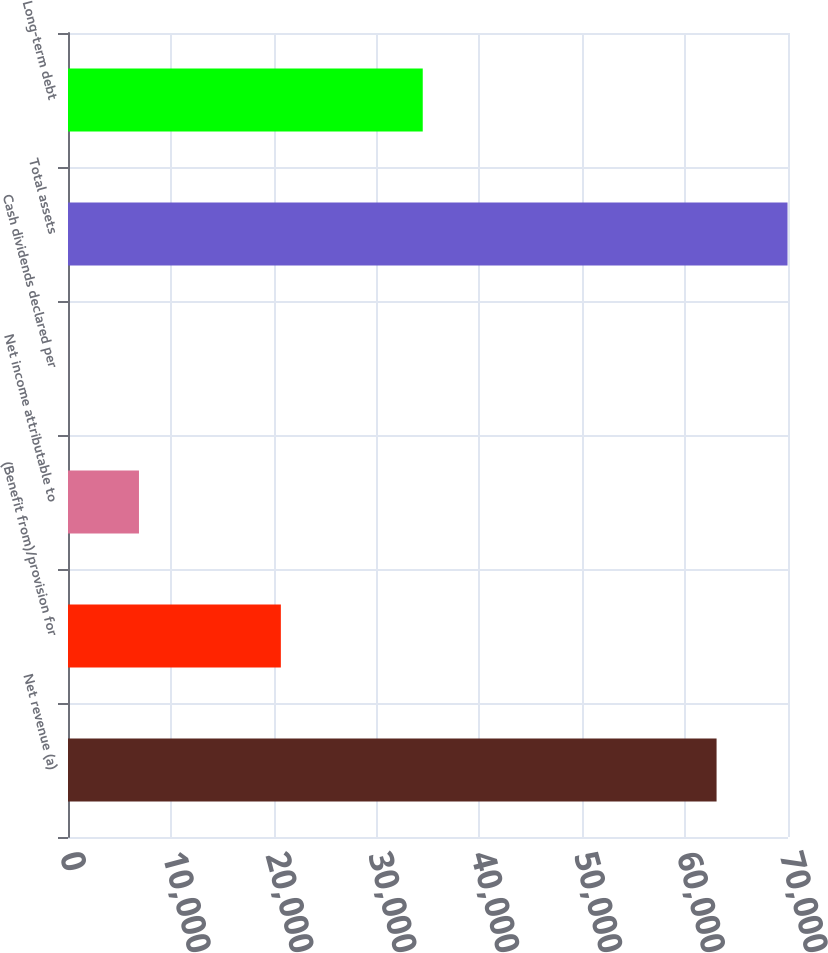Convert chart to OTSL. <chart><loc_0><loc_0><loc_500><loc_500><bar_chart><fcel>Net revenue (a)<fcel>(Benefit from)/provision for<fcel>Net income attributable to<fcel>Cash dividends declared per<fcel>Total assets<fcel>Long-term debt<nl><fcel>63056<fcel>20694.7<fcel>6900.08<fcel>2.76<fcel>69953.3<fcel>34489.4<nl></chart> 